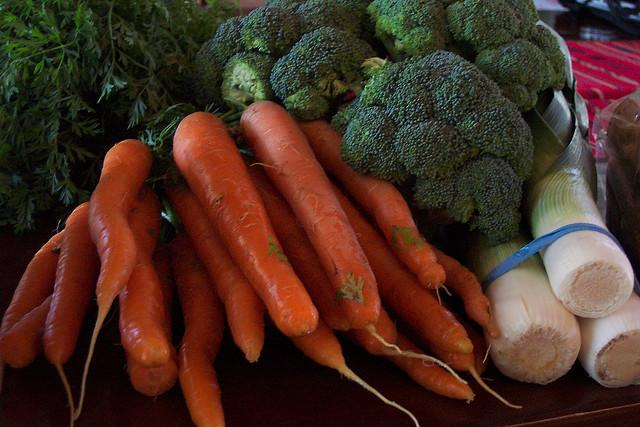What is a collective name given to the food options above? vegetables 